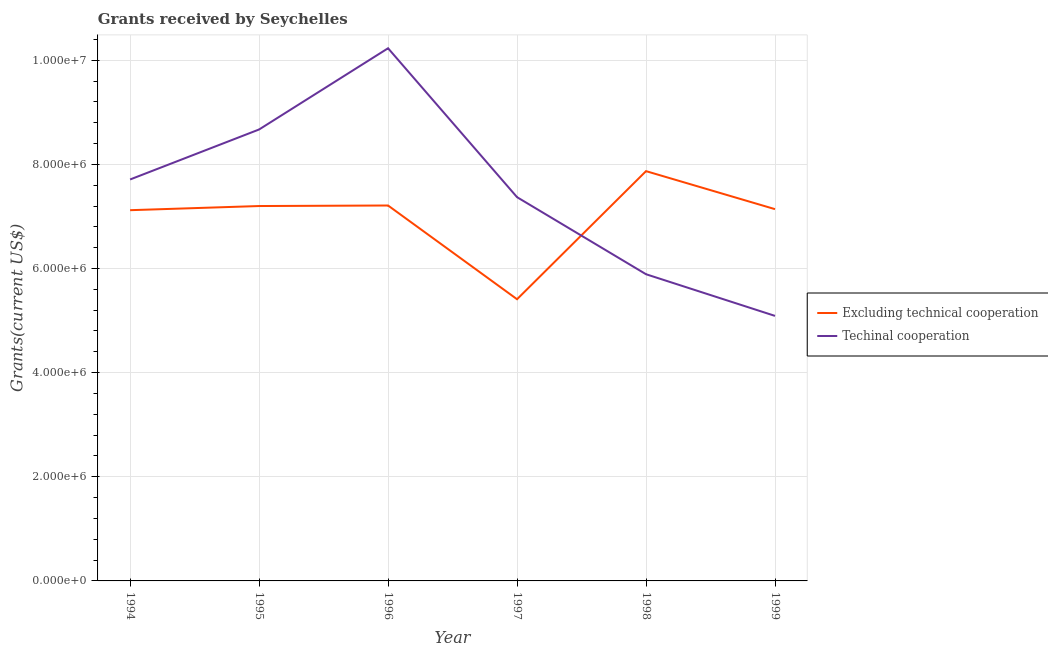Does the line corresponding to amount of grants received(including technical cooperation) intersect with the line corresponding to amount of grants received(excluding technical cooperation)?
Make the answer very short. Yes. Is the number of lines equal to the number of legend labels?
Your response must be concise. Yes. What is the amount of grants received(including technical cooperation) in 1999?
Provide a short and direct response. 5.09e+06. Across all years, what is the maximum amount of grants received(including technical cooperation)?
Your answer should be very brief. 1.02e+07. Across all years, what is the minimum amount of grants received(including technical cooperation)?
Your response must be concise. 5.09e+06. In which year was the amount of grants received(including technical cooperation) maximum?
Your answer should be compact. 1996. What is the total amount of grants received(excluding technical cooperation) in the graph?
Give a very brief answer. 4.20e+07. What is the difference between the amount of grants received(excluding technical cooperation) in 1997 and that in 1999?
Offer a very short reply. -1.73e+06. What is the difference between the amount of grants received(excluding technical cooperation) in 1994 and the amount of grants received(including technical cooperation) in 1997?
Ensure brevity in your answer.  -2.50e+05. What is the average amount of grants received(including technical cooperation) per year?
Provide a short and direct response. 7.49e+06. In the year 1999, what is the difference between the amount of grants received(excluding technical cooperation) and amount of grants received(including technical cooperation)?
Offer a terse response. 2.05e+06. What is the ratio of the amount of grants received(excluding technical cooperation) in 1994 to that in 1997?
Your answer should be very brief. 1.32. Is the amount of grants received(including technical cooperation) in 1996 less than that in 1998?
Provide a short and direct response. No. What is the difference between the highest and the second highest amount of grants received(excluding technical cooperation)?
Provide a short and direct response. 6.60e+05. What is the difference between the highest and the lowest amount of grants received(including technical cooperation)?
Provide a short and direct response. 5.14e+06. In how many years, is the amount of grants received(excluding technical cooperation) greater than the average amount of grants received(excluding technical cooperation) taken over all years?
Offer a very short reply. 5. Is the amount of grants received(excluding technical cooperation) strictly greater than the amount of grants received(including technical cooperation) over the years?
Offer a terse response. No. Are the values on the major ticks of Y-axis written in scientific E-notation?
Your answer should be very brief. Yes. Does the graph contain grids?
Your response must be concise. Yes. How many legend labels are there?
Your response must be concise. 2. How are the legend labels stacked?
Offer a very short reply. Vertical. What is the title of the graph?
Offer a terse response. Grants received by Seychelles. Does "Money lenders" appear as one of the legend labels in the graph?
Your answer should be compact. No. What is the label or title of the X-axis?
Provide a short and direct response. Year. What is the label or title of the Y-axis?
Provide a succinct answer. Grants(current US$). What is the Grants(current US$) in Excluding technical cooperation in 1994?
Your response must be concise. 7.12e+06. What is the Grants(current US$) in Techinal cooperation in 1994?
Your answer should be compact. 7.71e+06. What is the Grants(current US$) in Excluding technical cooperation in 1995?
Offer a terse response. 7.20e+06. What is the Grants(current US$) of Techinal cooperation in 1995?
Your answer should be very brief. 8.67e+06. What is the Grants(current US$) in Excluding technical cooperation in 1996?
Keep it short and to the point. 7.21e+06. What is the Grants(current US$) of Techinal cooperation in 1996?
Make the answer very short. 1.02e+07. What is the Grants(current US$) in Excluding technical cooperation in 1997?
Make the answer very short. 5.41e+06. What is the Grants(current US$) in Techinal cooperation in 1997?
Your answer should be compact. 7.37e+06. What is the Grants(current US$) in Excluding technical cooperation in 1998?
Your answer should be compact. 7.87e+06. What is the Grants(current US$) in Techinal cooperation in 1998?
Keep it short and to the point. 5.89e+06. What is the Grants(current US$) of Excluding technical cooperation in 1999?
Offer a very short reply. 7.14e+06. What is the Grants(current US$) of Techinal cooperation in 1999?
Offer a terse response. 5.09e+06. Across all years, what is the maximum Grants(current US$) of Excluding technical cooperation?
Make the answer very short. 7.87e+06. Across all years, what is the maximum Grants(current US$) of Techinal cooperation?
Provide a short and direct response. 1.02e+07. Across all years, what is the minimum Grants(current US$) in Excluding technical cooperation?
Keep it short and to the point. 5.41e+06. Across all years, what is the minimum Grants(current US$) in Techinal cooperation?
Your response must be concise. 5.09e+06. What is the total Grants(current US$) of Excluding technical cooperation in the graph?
Your answer should be compact. 4.20e+07. What is the total Grants(current US$) in Techinal cooperation in the graph?
Provide a succinct answer. 4.50e+07. What is the difference between the Grants(current US$) of Excluding technical cooperation in 1994 and that in 1995?
Give a very brief answer. -8.00e+04. What is the difference between the Grants(current US$) of Techinal cooperation in 1994 and that in 1995?
Give a very brief answer. -9.60e+05. What is the difference between the Grants(current US$) of Excluding technical cooperation in 1994 and that in 1996?
Provide a short and direct response. -9.00e+04. What is the difference between the Grants(current US$) in Techinal cooperation in 1994 and that in 1996?
Make the answer very short. -2.52e+06. What is the difference between the Grants(current US$) in Excluding technical cooperation in 1994 and that in 1997?
Give a very brief answer. 1.71e+06. What is the difference between the Grants(current US$) of Techinal cooperation in 1994 and that in 1997?
Offer a very short reply. 3.40e+05. What is the difference between the Grants(current US$) in Excluding technical cooperation in 1994 and that in 1998?
Your answer should be compact. -7.50e+05. What is the difference between the Grants(current US$) of Techinal cooperation in 1994 and that in 1998?
Provide a short and direct response. 1.82e+06. What is the difference between the Grants(current US$) of Techinal cooperation in 1994 and that in 1999?
Provide a succinct answer. 2.62e+06. What is the difference between the Grants(current US$) of Techinal cooperation in 1995 and that in 1996?
Your answer should be very brief. -1.56e+06. What is the difference between the Grants(current US$) in Excluding technical cooperation in 1995 and that in 1997?
Keep it short and to the point. 1.79e+06. What is the difference between the Grants(current US$) of Techinal cooperation in 1995 and that in 1997?
Your answer should be very brief. 1.30e+06. What is the difference between the Grants(current US$) in Excluding technical cooperation in 1995 and that in 1998?
Provide a succinct answer. -6.70e+05. What is the difference between the Grants(current US$) in Techinal cooperation in 1995 and that in 1998?
Keep it short and to the point. 2.78e+06. What is the difference between the Grants(current US$) in Techinal cooperation in 1995 and that in 1999?
Give a very brief answer. 3.58e+06. What is the difference between the Grants(current US$) in Excluding technical cooperation in 1996 and that in 1997?
Keep it short and to the point. 1.80e+06. What is the difference between the Grants(current US$) of Techinal cooperation in 1996 and that in 1997?
Your response must be concise. 2.86e+06. What is the difference between the Grants(current US$) of Excluding technical cooperation in 1996 and that in 1998?
Provide a short and direct response. -6.60e+05. What is the difference between the Grants(current US$) of Techinal cooperation in 1996 and that in 1998?
Offer a very short reply. 4.34e+06. What is the difference between the Grants(current US$) in Excluding technical cooperation in 1996 and that in 1999?
Ensure brevity in your answer.  7.00e+04. What is the difference between the Grants(current US$) of Techinal cooperation in 1996 and that in 1999?
Your answer should be compact. 5.14e+06. What is the difference between the Grants(current US$) in Excluding technical cooperation in 1997 and that in 1998?
Offer a terse response. -2.46e+06. What is the difference between the Grants(current US$) in Techinal cooperation in 1997 and that in 1998?
Your answer should be very brief. 1.48e+06. What is the difference between the Grants(current US$) in Excluding technical cooperation in 1997 and that in 1999?
Your response must be concise. -1.73e+06. What is the difference between the Grants(current US$) in Techinal cooperation in 1997 and that in 1999?
Provide a succinct answer. 2.28e+06. What is the difference between the Grants(current US$) of Excluding technical cooperation in 1998 and that in 1999?
Your answer should be compact. 7.30e+05. What is the difference between the Grants(current US$) of Techinal cooperation in 1998 and that in 1999?
Make the answer very short. 8.00e+05. What is the difference between the Grants(current US$) in Excluding technical cooperation in 1994 and the Grants(current US$) in Techinal cooperation in 1995?
Ensure brevity in your answer.  -1.55e+06. What is the difference between the Grants(current US$) in Excluding technical cooperation in 1994 and the Grants(current US$) in Techinal cooperation in 1996?
Offer a terse response. -3.11e+06. What is the difference between the Grants(current US$) in Excluding technical cooperation in 1994 and the Grants(current US$) in Techinal cooperation in 1998?
Your answer should be compact. 1.23e+06. What is the difference between the Grants(current US$) of Excluding technical cooperation in 1994 and the Grants(current US$) of Techinal cooperation in 1999?
Offer a terse response. 2.03e+06. What is the difference between the Grants(current US$) in Excluding technical cooperation in 1995 and the Grants(current US$) in Techinal cooperation in 1996?
Your answer should be compact. -3.03e+06. What is the difference between the Grants(current US$) in Excluding technical cooperation in 1995 and the Grants(current US$) in Techinal cooperation in 1998?
Keep it short and to the point. 1.31e+06. What is the difference between the Grants(current US$) in Excluding technical cooperation in 1995 and the Grants(current US$) in Techinal cooperation in 1999?
Give a very brief answer. 2.11e+06. What is the difference between the Grants(current US$) in Excluding technical cooperation in 1996 and the Grants(current US$) in Techinal cooperation in 1997?
Your answer should be very brief. -1.60e+05. What is the difference between the Grants(current US$) in Excluding technical cooperation in 1996 and the Grants(current US$) in Techinal cooperation in 1998?
Give a very brief answer. 1.32e+06. What is the difference between the Grants(current US$) in Excluding technical cooperation in 1996 and the Grants(current US$) in Techinal cooperation in 1999?
Keep it short and to the point. 2.12e+06. What is the difference between the Grants(current US$) of Excluding technical cooperation in 1997 and the Grants(current US$) of Techinal cooperation in 1998?
Give a very brief answer. -4.80e+05. What is the difference between the Grants(current US$) of Excluding technical cooperation in 1997 and the Grants(current US$) of Techinal cooperation in 1999?
Ensure brevity in your answer.  3.20e+05. What is the difference between the Grants(current US$) in Excluding technical cooperation in 1998 and the Grants(current US$) in Techinal cooperation in 1999?
Ensure brevity in your answer.  2.78e+06. What is the average Grants(current US$) of Excluding technical cooperation per year?
Your answer should be compact. 6.99e+06. What is the average Grants(current US$) in Techinal cooperation per year?
Your answer should be very brief. 7.49e+06. In the year 1994, what is the difference between the Grants(current US$) of Excluding technical cooperation and Grants(current US$) of Techinal cooperation?
Give a very brief answer. -5.90e+05. In the year 1995, what is the difference between the Grants(current US$) in Excluding technical cooperation and Grants(current US$) in Techinal cooperation?
Your response must be concise. -1.47e+06. In the year 1996, what is the difference between the Grants(current US$) in Excluding technical cooperation and Grants(current US$) in Techinal cooperation?
Provide a succinct answer. -3.02e+06. In the year 1997, what is the difference between the Grants(current US$) in Excluding technical cooperation and Grants(current US$) in Techinal cooperation?
Offer a very short reply. -1.96e+06. In the year 1998, what is the difference between the Grants(current US$) of Excluding technical cooperation and Grants(current US$) of Techinal cooperation?
Make the answer very short. 1.98e+06. In the year 1999, what is the difference between the Grants(current US$) in Excluding technical cooperation and Grants(current US$) in Techinal cooperation?
Offer a terse response. 2.05e+06. What is the ratio of the Grants(current US$) in Excluding technical cooperation in 1994 to that in 1995?
Your answer should be very brief. 0.99. What is the ratio of the Grants(current US$) of Techinal cooperation in 1994 to that in 1995?
Provide a short and direct response. 0.89. What is the ratio of the Grants(current US$) of Excluding technical cooperation in 1994 to that in 1996?
Your response must be concise. 0.99. What is the ratio of the Grants(current US$) of Techinal cooperation in 1994 to that in 1996?
Provide a succinct answer. 0.75. What is the ratio of the Grants(current US$) in Excluding technical cooperation in 1994 to that in 1997?
Offer a very short reply. 1.32. What is the ratio of the Grants(current US$) in Techinal cooperation in 1994 to that in 1997?
Offer a terse response. 1.05. What is the ratio of the Grants(current US$) of Excluding technical cooperation in 1994 to that in 1998?
Offer a terse response. 0.9. What is the ratio of the Grants(current US$) of Techinal cooperation in 1994 to that in 1998?
Give a very brief answer. 1.31. What is the ratio of the Grants(current US$) of Techinal cooperation in 1994 to that in 1999?
Keep it short and to the point. 1.51. What is the ratio of the Grants(current US$) in Techinal cooperation in 1995 to that in 1996?
Keep it short and to the point. 0.85. What is the ratio of the Grants(current US$) in Excluding technical cooperation in 1995 to that in 1997?
Make the answer very short. 1.33. What is the ratio of the Grants(current US$) of Techinal cooperation in 1995 to that in 1997?
Your answer should be compact. 1.18. What is the ratio of the Grants(current US$) of Excluding technical cooperation in 1995 to that in 1998?
Provide a succinct answer. 0.91. What is the ratio of the Grants(current US$) of Techinal cooperation in 1995 to that in 1998?
Provide a succinct answer. 1.47. What is the ratio of the Grants(current US$) in Excluding technical cooperation in 1995 to that in 1999?
Provide a succinct answer. 1.01. What is the ratio of the Grants(current US$) in Techinal cooperation in 1995 to that in 1999?
Provide a succinct answer. 1.7. What is the ratio of the Grants(current US$) in Excluding technical cooperation in 1996 to that in 1997?
Give a very brief answer. 1.33. What is the ratio of the Grants(current US$) of Techinal cooperation in 1996 to that in 1997?
Keep it short and to the point. 1.39. What is the ratio of the Grants(current US$) in Excluding technical cooperation in 1996 to that in 1998?
Your answer should be very brief. 0.92. What is the ratio of the Grants(current US$) of Techinal cooperation in 1996 to that in 1998?
Your response must be concise. 1.74. What is the ratio of the Grants(current US$) in Excluding technical cooperation in 1996 to that in 1999?
Your answer should be very brief. 1.01. What is the ratio of the Grants(current US$) of Techinal cooperation in 1996 to that in 1999?
Provide a succinct answer. 2.01. What is the ratio of the Grants(current US$) of Excluding technical cooperation in 1997 to that in 1998?
Your answer should be very brief. 0.69. What is the ratio of the Grants(current US$) of Techinal cooperation in 1997 to that in 1998?
Offer a terse response. 1.25. What is the ratio of the Grants(current US$) of Excluding technical cooperation in 1997 to that in 1999?
Your answer should be compact. 0.76. What is the ratio of the Grants(current US$) of Techinal cooperation in 1997 to that in 1999?
Your response must be concise. 1.45. What is the ratio of the Grants(current US$) of Excluding technical cooperation in 1998 to that in 1999?
Give a very brief answer. 1.1. What is the ratio of the Grants(current US$) of Techinal cooperation in 1998 to that in 1999?
Your response must be concise. 1.16. What is the difference between the highest and the second highest Grants(current US$) of Excluding technical cooperation?
Your answer should be compact. 6.60e+05. What is the difference between the highest and the second highest Grants(current US$) of Techinal cooperation?
Offer a terse response. 1.56e+06. What is the difference between the highest and the lowest Grants(current US$) in Excluding technical cooperation?
Ensure brevity in your answer.  2.46e+06. What is the difference between the highest and the lowest Grants(current US$) of Techinal cooperation?
Offer a terse response. 5.14e+06. 